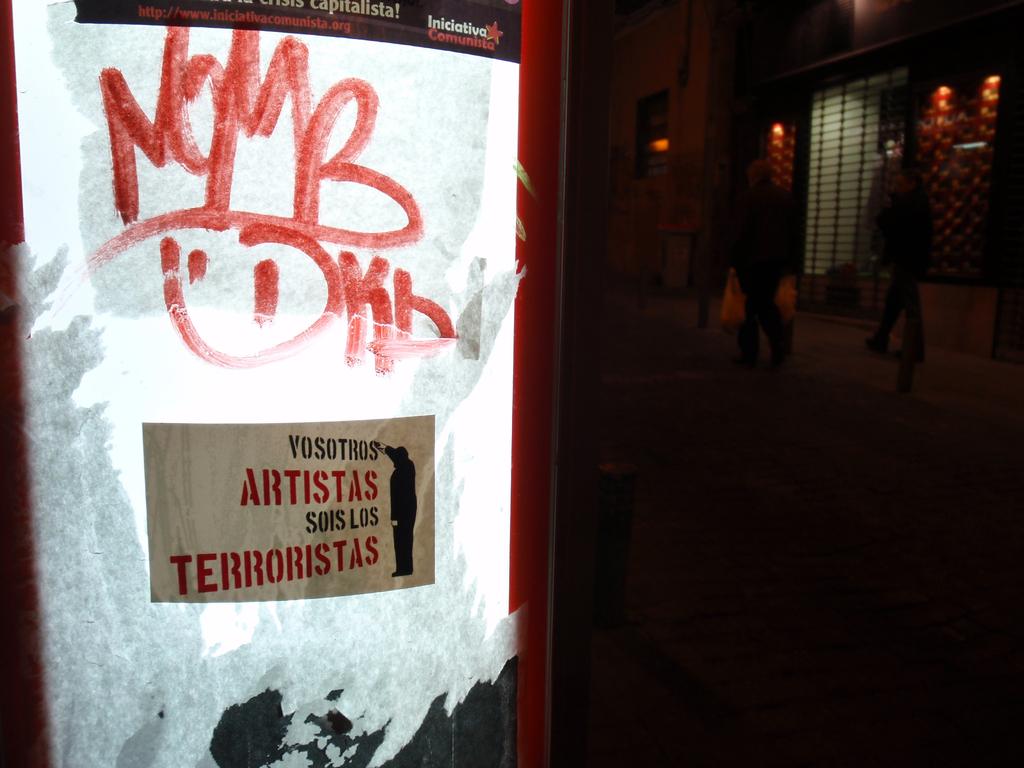What are the letters scribbled on the board?
Offer a very short reply. Nomb. Nice signature, does it have to do with terrorist artists?
Your answer should be very brief. Yes. 